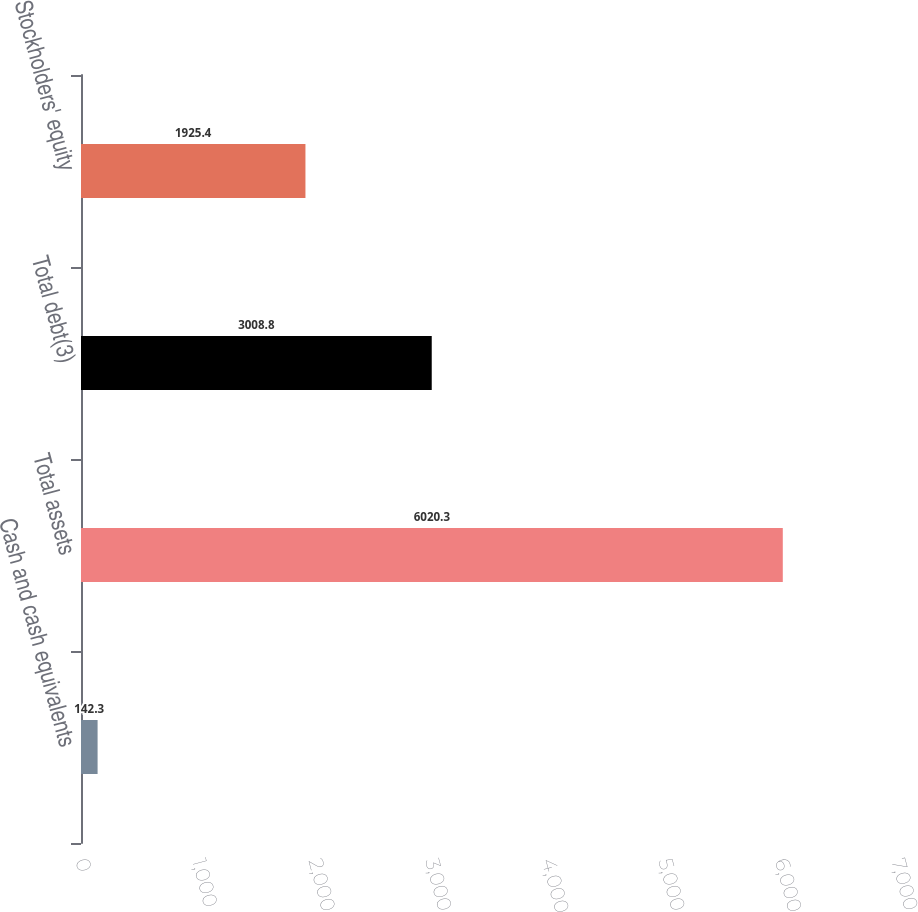<chart> <loc_0><loc_0><loc_500><loc_500><bar_chart><fcel>Cash and cash equivalents<fcel>Total assets<fcel>Total debt(3)<fcel>Stockholders' equity<nl><fcel>142.3<fcel>6020.3<fcel>3008.8<fcel>1925.4<nl></chart> 